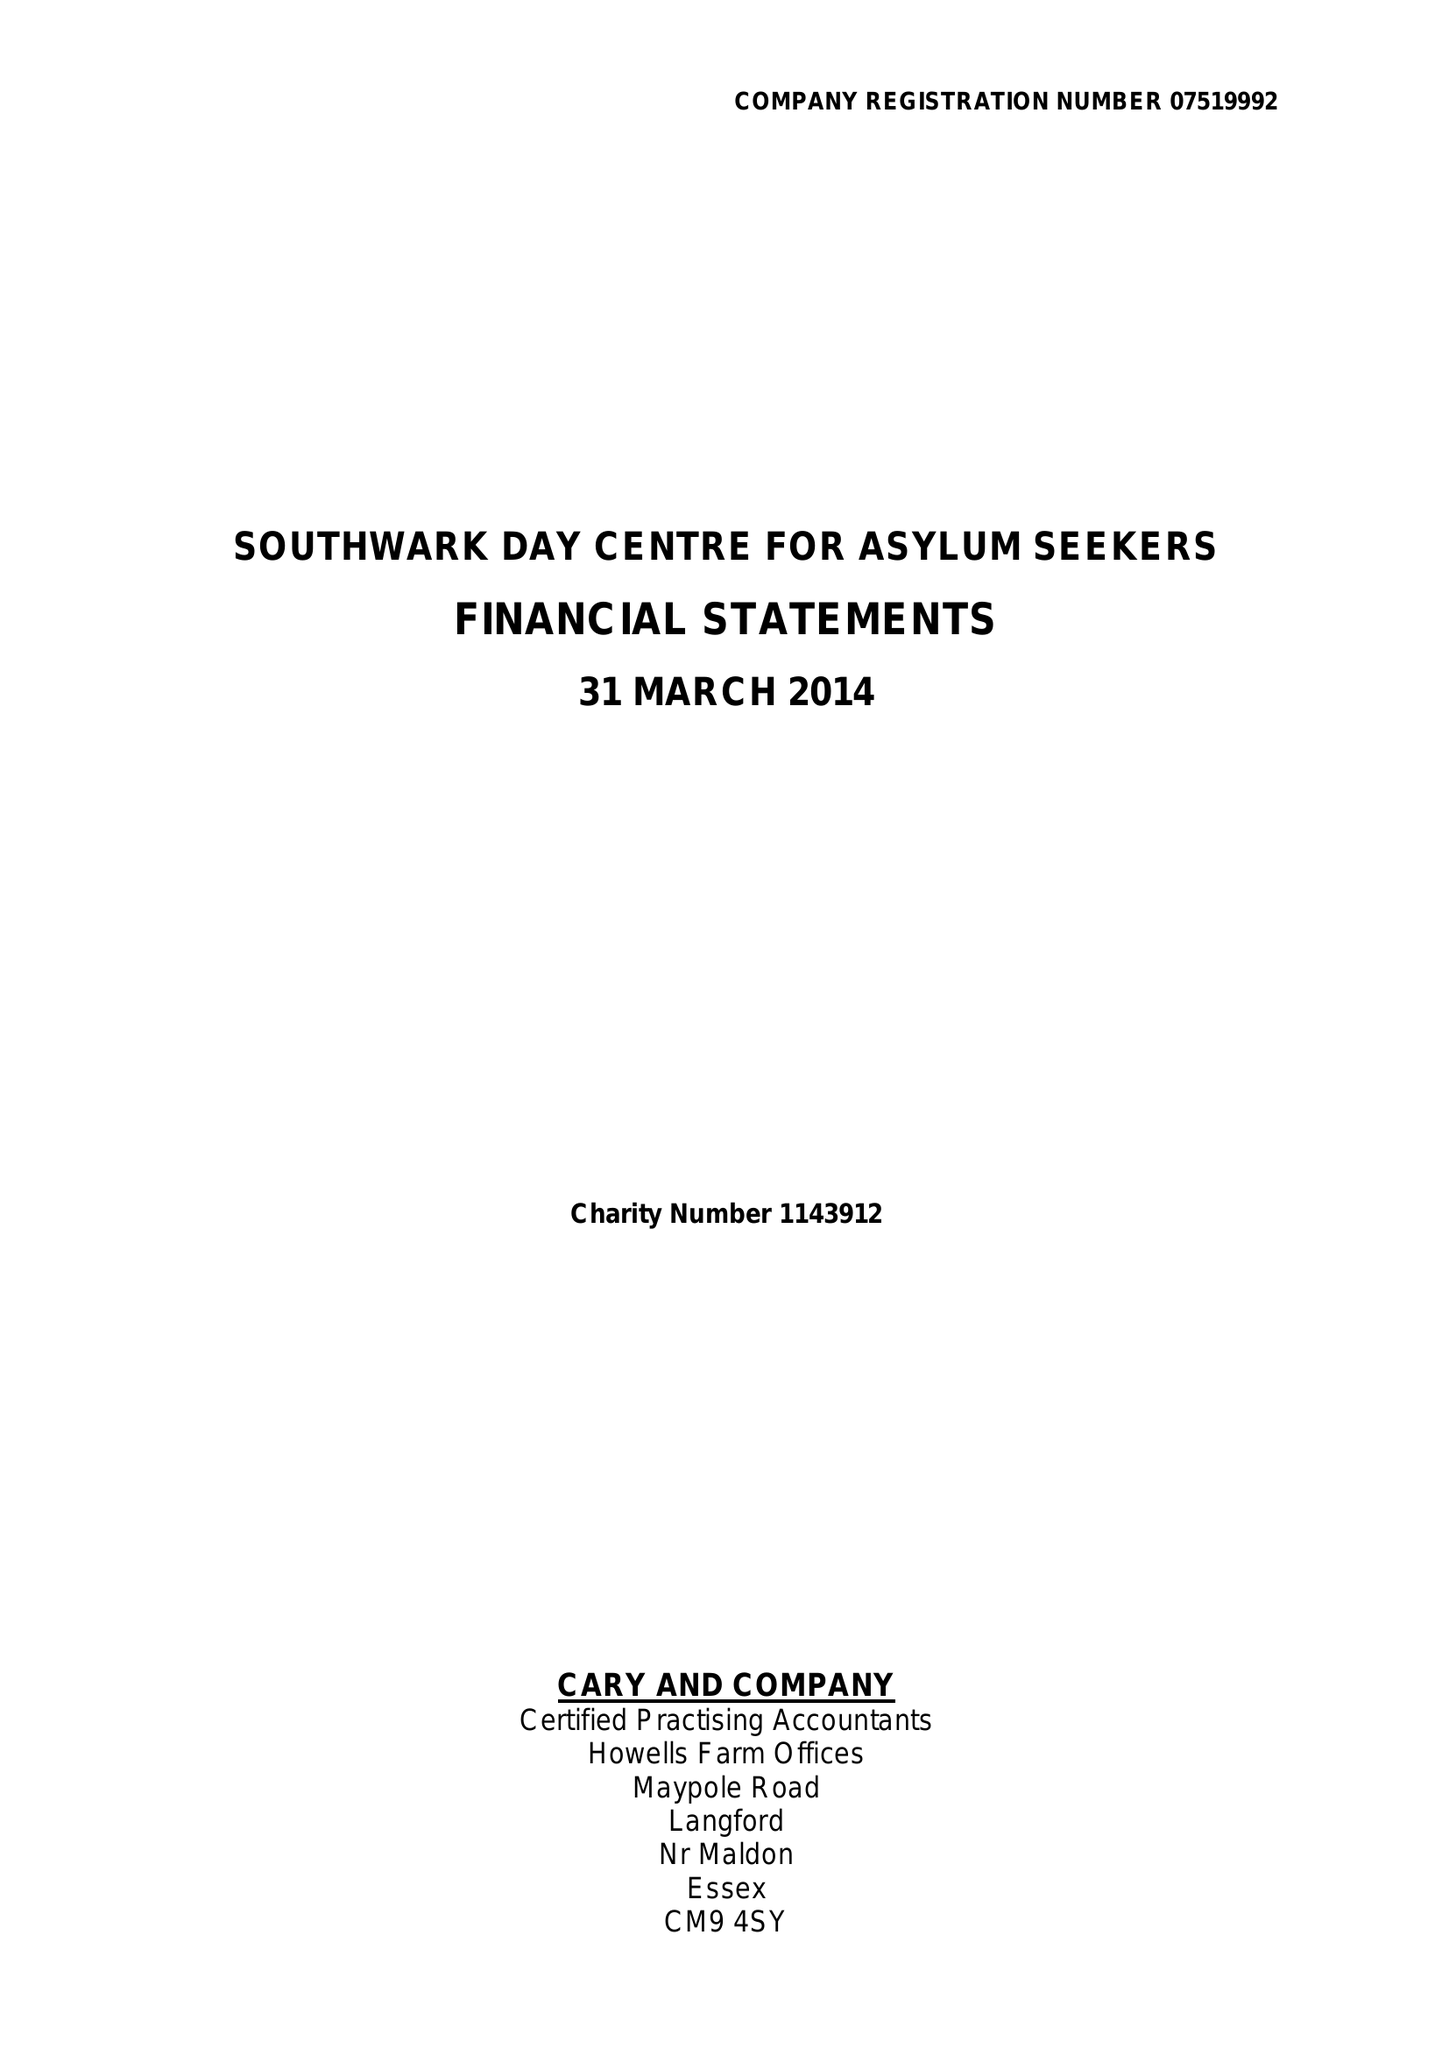What is the value for the spending_annually_in_british_pounds?
Answer the question using a single word or phrase. 204562.00 